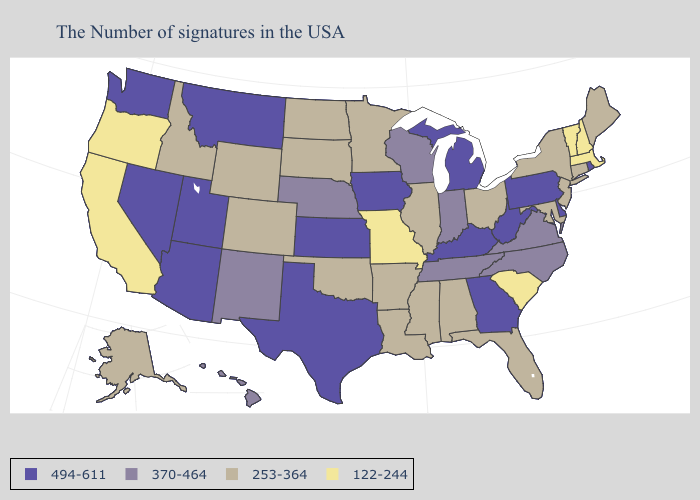What is the lowest value in the Northeast?
Keep it brief. 122-244. Name the states that have a value in the range 370-464?
Short answer required. Virginia, North Carolina, Indiana, Tennessee, Wisconsin, Nebraska, New Mexico, Hawaii. Among the states that border Texas , does Oklahoma have the highest value?
Write a very short answer. No. Name the states that have a value in the range 494-611?
Write a very short answer. Rhode Island, Delaware, Pennsylvania, West Virginia, Georgia, Michigan, Kentucky, Iowa, Kansas, Texas, Utah, Montana, Arizona, Nevada, Washington. What is the highest value in states that border Washington?
Concise answer only. 253-364. Name the states that have a value in the range 494-611?
Answer briefly. Rhode Island, Delaware, Pennsylvania, West Virginia, Georgia, Michigan, Kentucky, Iowa, Kansas, Texas, Utah, Montana, Arizona, Nevada, Washington. Name the states that have a value in the range 122-244?
Give a very brief answer. Massachusetts, New Hampshire, Vermont, South Carolina, Missouri, California, Oregon. Does Montana have the lowest value in the USA?
Be succinct. No. What is the value of California?
Answer briefly. 122-244. Name the states that have a value in the range 253-364?
Keep it brief. Maine, Connecticut, New York, New Jersey, Maryland, Ohio, Florida, Alabama, Illinois, Mississippi, Louisiana, Arkansas, Minnesota, Oklahoma, South Dakota, North Dakota, Wyoming, Colorado, Idaho, Alaska. What is the value of Texas?
Quick response, please. 494-611. Does Alabama have the highest value in the South?
Quick response, please. No. Which states have the lowest value in the South?
Give a very brief answer. South Carolina. How many symbols are there in the legend?
Write a very short answer. 4. Which states have the highest value in the USA?
Answer briefly. Rhode Island, Delaware, Pennsylvania, West Virginia, Georgia, Michigan, Kentucky, Iowa, Kansas, Texas, Utah, Montana, Arizona, Nevada, Washington. 